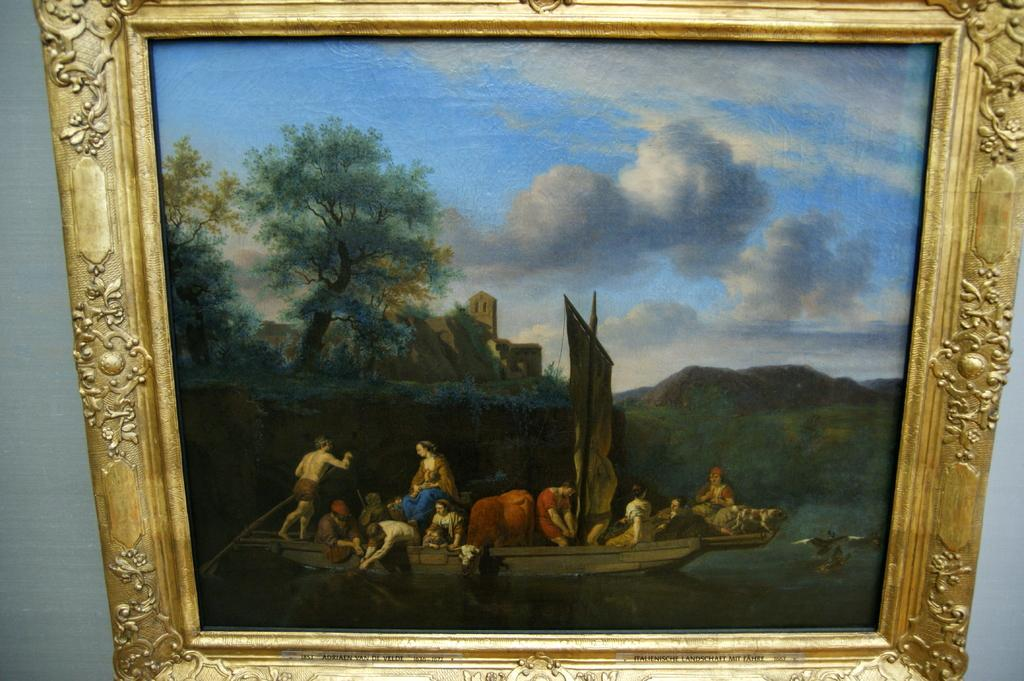What object can be seen in the image that is typically used for displaying photos? There is a photo frame in the image. Where is the photo frame located in the image? The photo frame is placed on a wall. What type of cabbage is hanging from the ceiling in the image? There is no cabbage present in the image; it only features a photo frame placed on a wall. 